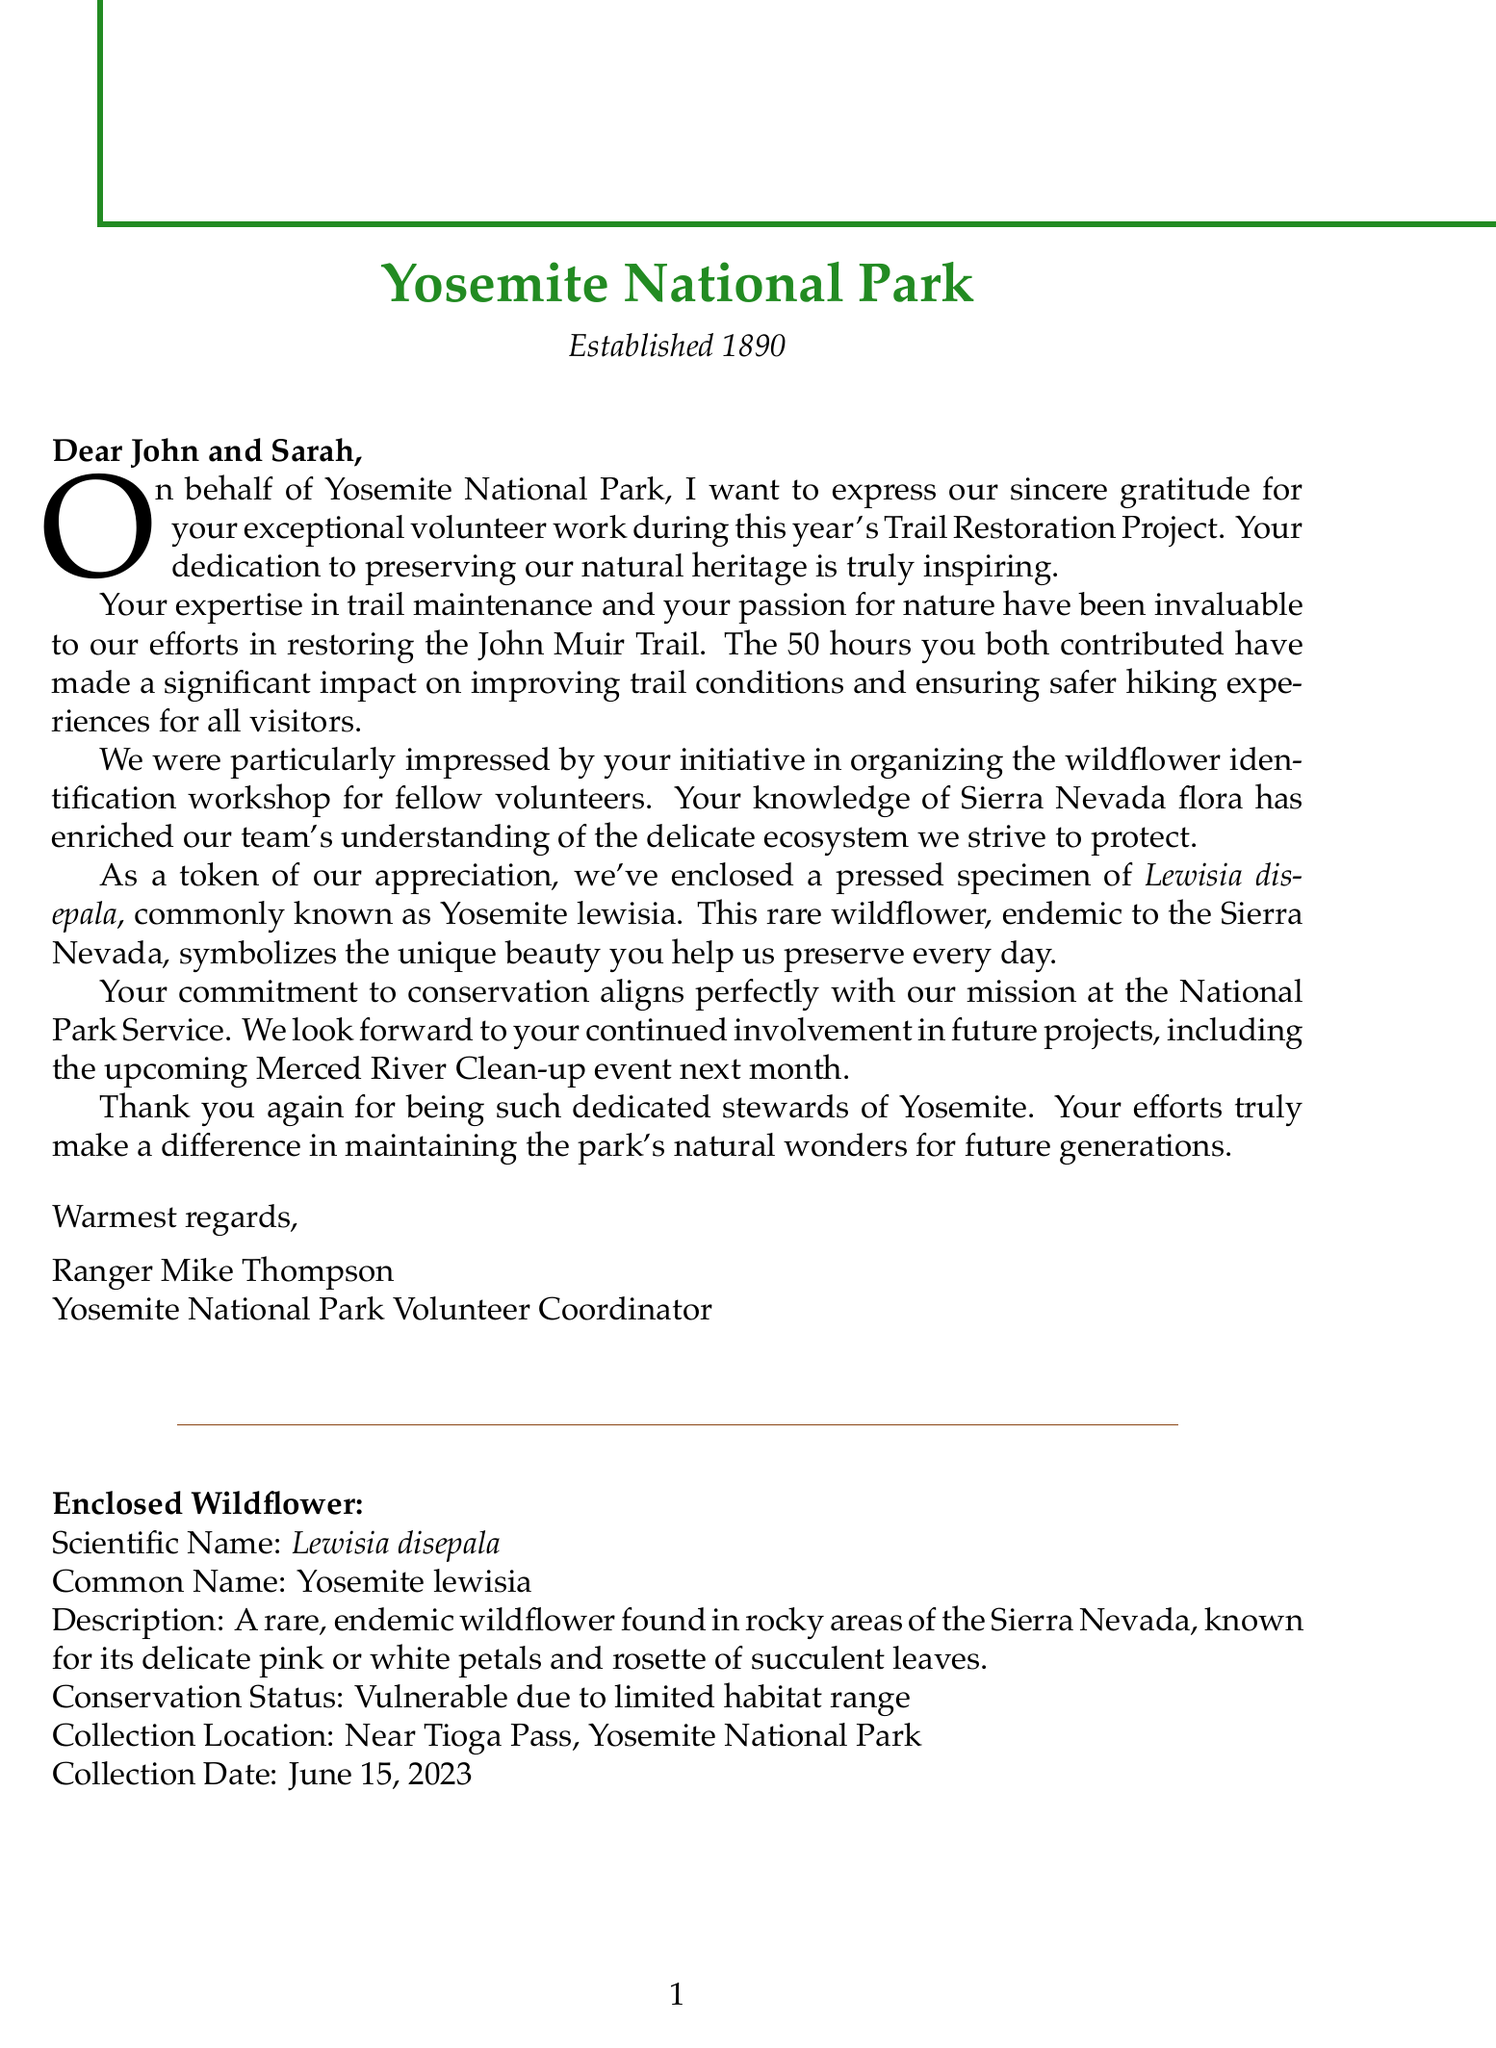What is the name of the national park mentioned in the letter? The letter is addressed to a couple and acknowledges their volunteer work at Yosemite National Park.
Answer: Yosemite National Park Who is the letter signed by? The letter includes a signature from the volunteer coordinator at Yosemite National Park.
Answer: Ranger Mike Thompson What is the common name of the enclosed wildflower? The letter mentions a specific wildflower that is enclosed as a token of appreciation.
Answer: Yosemite lewisia How many hours did John and Sarah volunteer? According to the letter, their volunteer contribution is specified in terms of hours contributed.
Answer: 50 What project did John and Sarah participate in? The letter refers to a specific project they contributed to during their volunteer work.
Answer: Trail Restoration Project What is the conservation status of the rare wildflower mentioned? The letter provides information about the conservation status of the wildflower and indicates its preservation concerns.
Answer: Vulnerable What event is mentioned for future involvement? The letter looks ahead to another event in which the couple is invited to participate, showing ongoing engagement.
Answer: Merced River Clean-up Where was the wildflower collected? The letter specifies a geographic location regarding the collection of the wildflower specimen.
Answer: Near Tioga Pass, Yosemite National Park What is one specific contribution John and Sarah made? The letter lists certain contributions they made to the volunteer project, highlighting their active role.
Answer: Organized wildflower identification workshop 